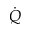<formula> <loc_0><loc_0><loc_500><loc_500>\dot { Q }</formula> 